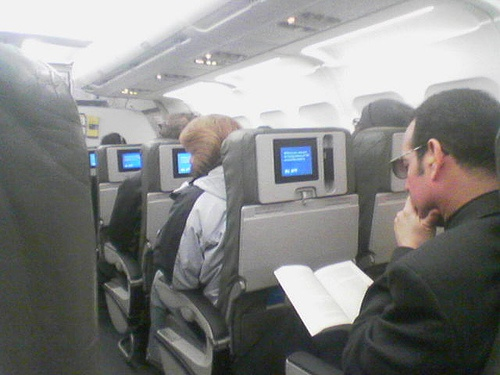Describe the objects in this image and their specific colors. I can see people in white, black, gray, and tan tones, people in white, gray, darkgray, lightgray, and black tones, book in white, gray, darkgray, and beige tones, people in white, black, gray, darkgray, and purple tones, and tv in white, gray, and lightblue tones in this image. 